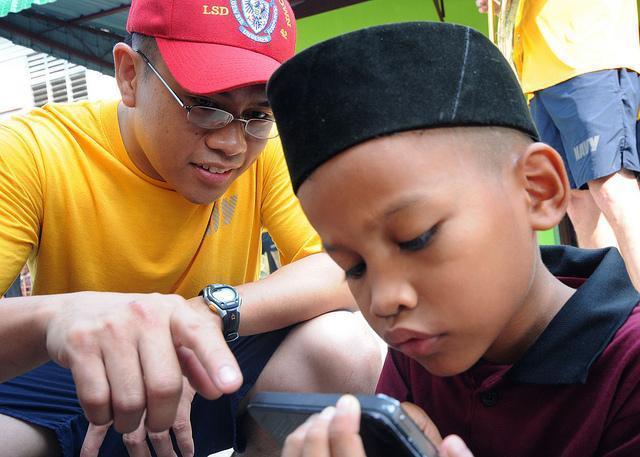How many cell phones can you see?
Give a very brief answer. 2. How many people are there?
Give a very brief answer. 3. 